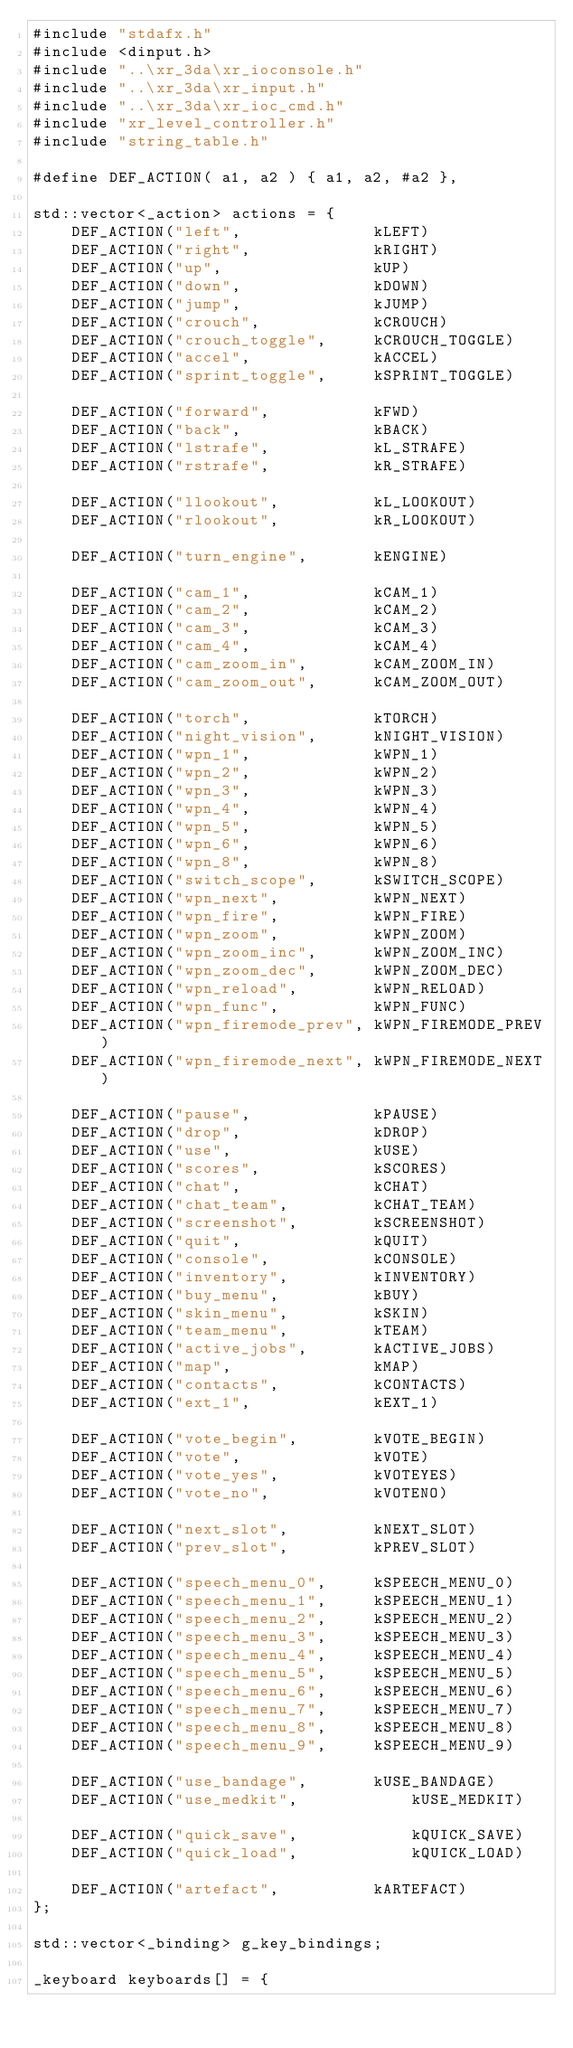Convert code to text. <code><loc_0><loc_0><loc_500><loc_500><_C++_>#include "stdafx.h"
#include <dinput.h>
#include "..\xr_3da\xr_ioconsole.h"
#include "..\xr_3da\xr_input.h"
#include "..\xr_3da\xr_ioc_cmd.h"
#include "xr_level_controller.h"
#include "string_table.h"

#define DEF_ACTION( a1, a2 ) { a1, a2, #a2 },

std::vector<_action> actions = {
	DEF_ACTION("left",				kLEFT)
	DEF_ACTION("right",				kRIGHT)
	DEF_ACTION("up",				kUP)
	DEF_ACTION("down",				kDOWN)
	DEF_ACTION("jump",				kJUMP)
	DEF_ACTION("crouch",			kCROUCH)
	DEF_ACTION("crouch_toggle",		kCROUCH_TOGGLE)
	DEF_ACTION("accel",				kACCEL)
	DEF_ACTION("sprint_toggle",  	kSPRINT_TOGGLE)

	DEF_ACTION("forward",			kFWD)
	DEF_ACTION("back",				kBACK)
	DEF_ACTION("lstrafe",			kL_STRAFE)
	DEF_ACTION("rstrafe",			kR_STRAFE)

	DEF_ACTION("llookout",			kL_LOOKOUT)
	DEF_ACTION("rlookout",			kR_LOOKOUT)

	DEF_ACTION("turn_engine",		kENGINE)

	DEF_ACTION("cam_1",				kCAM_1)
	DEF_ACTION("cam_2",				kCAM_2)
	DEF_ACTION("cam_3",				kCAM_3)
	DEF_ACTION("cam_4",				kCAM_4)
	DEF_ACTION("cam_zoom_in",		kCAM_ZOOM_IN)
	DEF_ACTION("cam_zoom_out",		kCAM_ZOOM_OUT)

	DEF_ACTION("torch",				kTORCH)
	DEF_ACTION("night_vision",		kNIGHT_VISION)
	DEF_ACTION("wpn_1",				kWPN_1)
	DEF_ACTION("wpn_2",				kWPN_2)
	DEF_ACTION("wpn_3",				kWPN_3)
	DEF_ACTION("wpn_4",				kWPN_4)
	DEF_ACTION("wpn_5",				kWPN_5)
	DEF_ACTION("wpn_6",				kWPN_6)
	DEF_ACTION("wpn_8",				kWPN_8)
	DEF_ACTION("switch_scope",		kSWITCH_SCOPE)
	DEF_ACTION("wpn_next",			kWPN_NEXT)
	DEF_ACTION("wpn_fire",			kWPN_FIRE)
	DEF_ACTION("wpn_zoom",			kWPN_ZOOM)
	DEF_ACTION("wpn_zoom_inc",		kWPN_ZOOM_INC)
	DEF_ACTION("wpn_zoom_dec",		kWPN_ZOOM_DEC)
	DEF_ACTION("wpn_reload",		kWPN_RELOAD)
	DEF_ACTION("wpn_func",			kWPN_FUNC)
	DEF_ACTION("wpn_firemode_prev",	kWPN_FIREMODE_PREV)
	DEF_ACTION("wpn_firemode_next",	kWPN_FIREMODE_NEXT)

	DEF_ACTION("pause",				kPAUSE)
	DEF_ACTION("drop",				kDROP)
	DEF_ACTION("use",				kUSE)
	DEF_ACTION("scores",			kSCORES)
	DEF_ACTION("chat",				kCHAT)
	DEF_ACTION("chat_team",			kCHAT_TEAM)
	DEF_ACTION("screenshot",		kSCREENSHOT)
	DEF_ACTION("quit",				kQUIT)
	DEF_ACTION("console",			kCONSOLE)
	DEF_ACTION("inventory",			kINVENTORY)
	DEF_ACTION("buy_menu",			kBUY)
	DEF_ACTION("skin_menu",			kSKIN)
	DEF_ACTION("team_menu",			kTEAM)
	DEF_ACTION("active_jobs",		kACTIVE_JOBS)
	DEF_ACTION("map",				kMAP)
	DEF_ACTION("contacts",			kCONTACTS)
	DEF_ACTION("ext_1",				kEXT_1)

	DEF_ACTION("vote_begin",		kVOTE_BEGIN)
	DEF_ACTION("vote",				kVOTE)
	DEF_ACTION("vote_yes",			kVOTEYES)
	DEF_ACTION("vote_no",			kVOTENO)

	DEF_ACTION("next_slot",			kNEXT_SLOT)
	DEF_ACTION("prev_slot",			kPREV_SLOT)

	DEF_ACTION("speech_menu_0",		kSPEECH_MENU_0)
	DEF_ACTION("speech_menu_1",		kSPEECH_MENU_1)
	DEF_ACTION("speech_menu_2",		kSPEECH_MENU_2)
	DEF_ACTION("speech_menu_3",		kSPEECH_MENU_3)
	DEF_ACTION("speech_menu_4",		kSPEECH_MENU_4)
	DEF_ACTION("speech_menu_5",		kSPEECH_MENU_5)
	DEF_ACTION("speech_menu_6",		kSPEECH_MENU_6)
	DEF_ACTION("speech_menu_7",		kSPEECH_MENU_7)
	DEF_ACTION("speech_menu_8",		kSPEECH_MENU_8)
	DEF_ACTION("speech_menu_9",		kSPEECH_MENU_9)

	DEF_ACTION("use_bandage",		kUSE_BANDAGE)
	DEF_ACTION("use_medkit",			kUSE_MEDKIT)

	DEF_ACTION("quick_save",			kQUICK_SAVE)
	DEF_ACTION("quick_load",			kQUICK_LOAD)

	DEF_ACTION("artefact",			kARTEFACT)
};

std::vector<_binding> g_key_bindings;

_keyboard keyboards[] = {</code> 